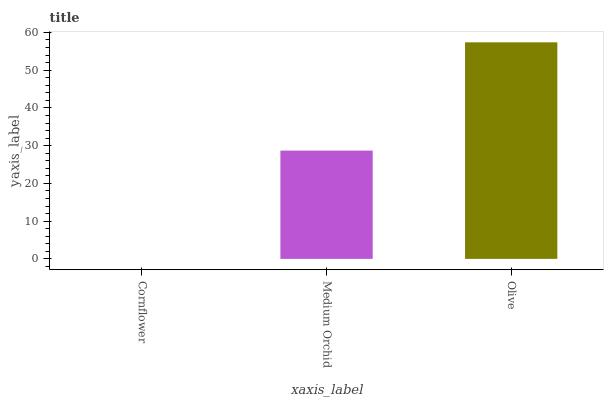Is Cornflower the minimum?
Answer yes or no. Yes. Is Olive the maximum?
Answer yes or no. Yes. Is Medium Orchid the minimum?
Answer yes or no. No. Is Medium Orchid the maximum?
Answer yes or no. No. Is Medium Orchid greater than Cornflower?
Answer yes or no. Yes. Is Cornflower less than Medium Orchid?
Answer yes or no. Yes. Is Cornflower greater than Medium Orchid?
Answer yes or no. No. Is Medium Orchid less than Cornflower?
Answer yes or no. No. Is Medium Orchid the high median?
Answer yes or no. Yes. Is Medium Orchid the low median?
Answer yes or no. Yes. Is Cornflower the high median?
Answer yes or no. No. Is Cornflower the low median?
Answer yes or no. No. 